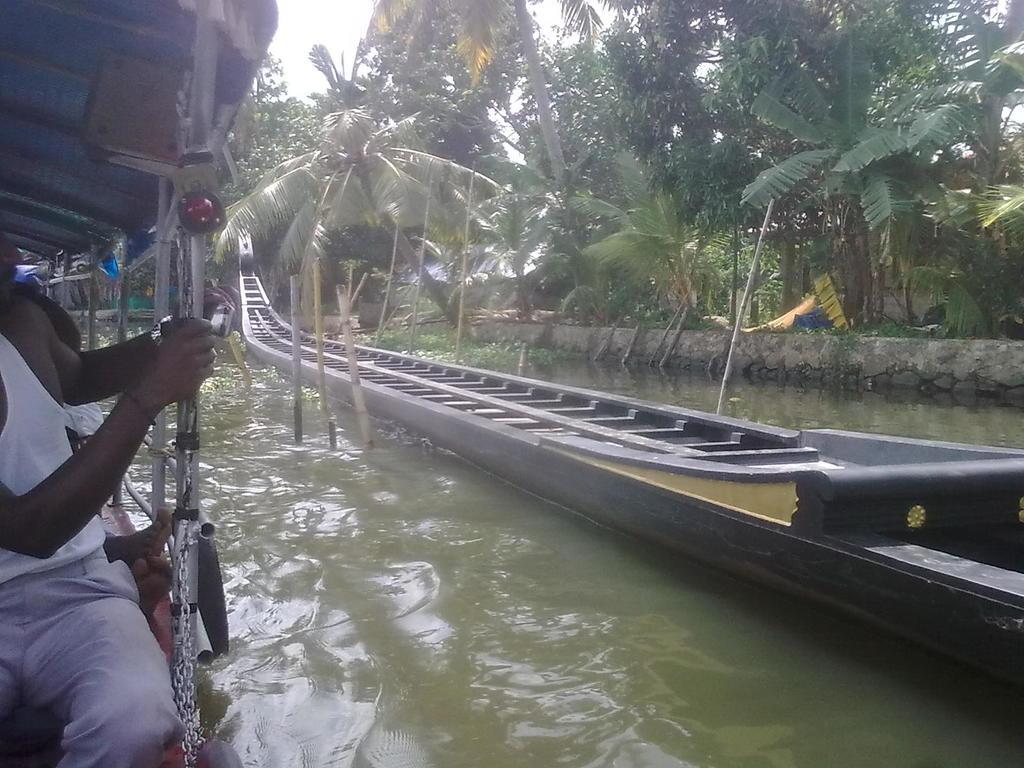What is in the water in the image? There is a boat in the water in the image. Who or what is inside the boat? A person is sitting in the boat. What can be seen in the background of the image? There are trees visible in the image. What part of the natural environment is visible in the image? The sky is visible in the image. What type of argument is taking place between the trees in the image? There is no argument taking place between the trees in the image; they are simply visible in the background. 